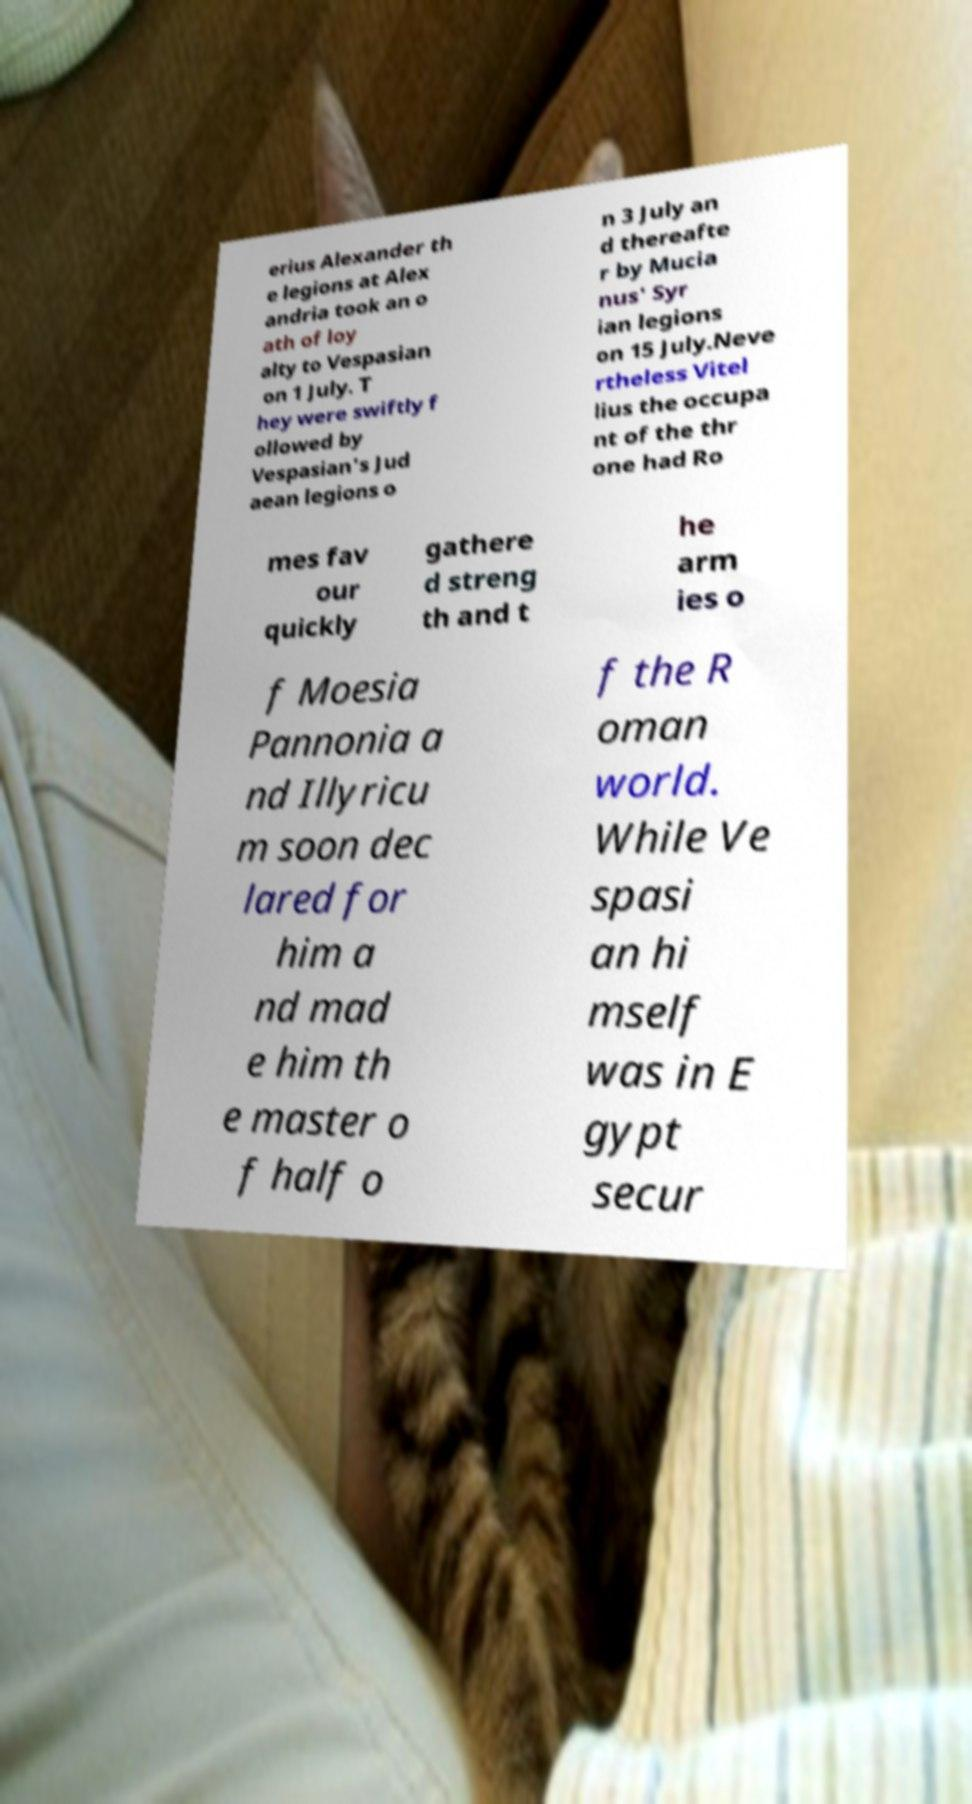What messages or text are displayed in this image? I need them in a readable, typed format. erius Alexander th e legions at Alex andria took an o ath of loy alty to Vespasian on 1 July. T hey were swiftly f ollowed by Vespasian's Jud aean legions o n 3 July an d thereafte r by Mucia nus' Syr ian legions on 15 July.Neve rtheless Vitel lius the occupa nt of the thr one had Ro mes fav our quickly gathere d streng th and t he arm ies o f Moesia Pannonia a nd Illyricu m soon dec lared for him a nd mad e him th e master o f half o f the R oman world. While Ve spasi an hi mself was in E gypt secur 